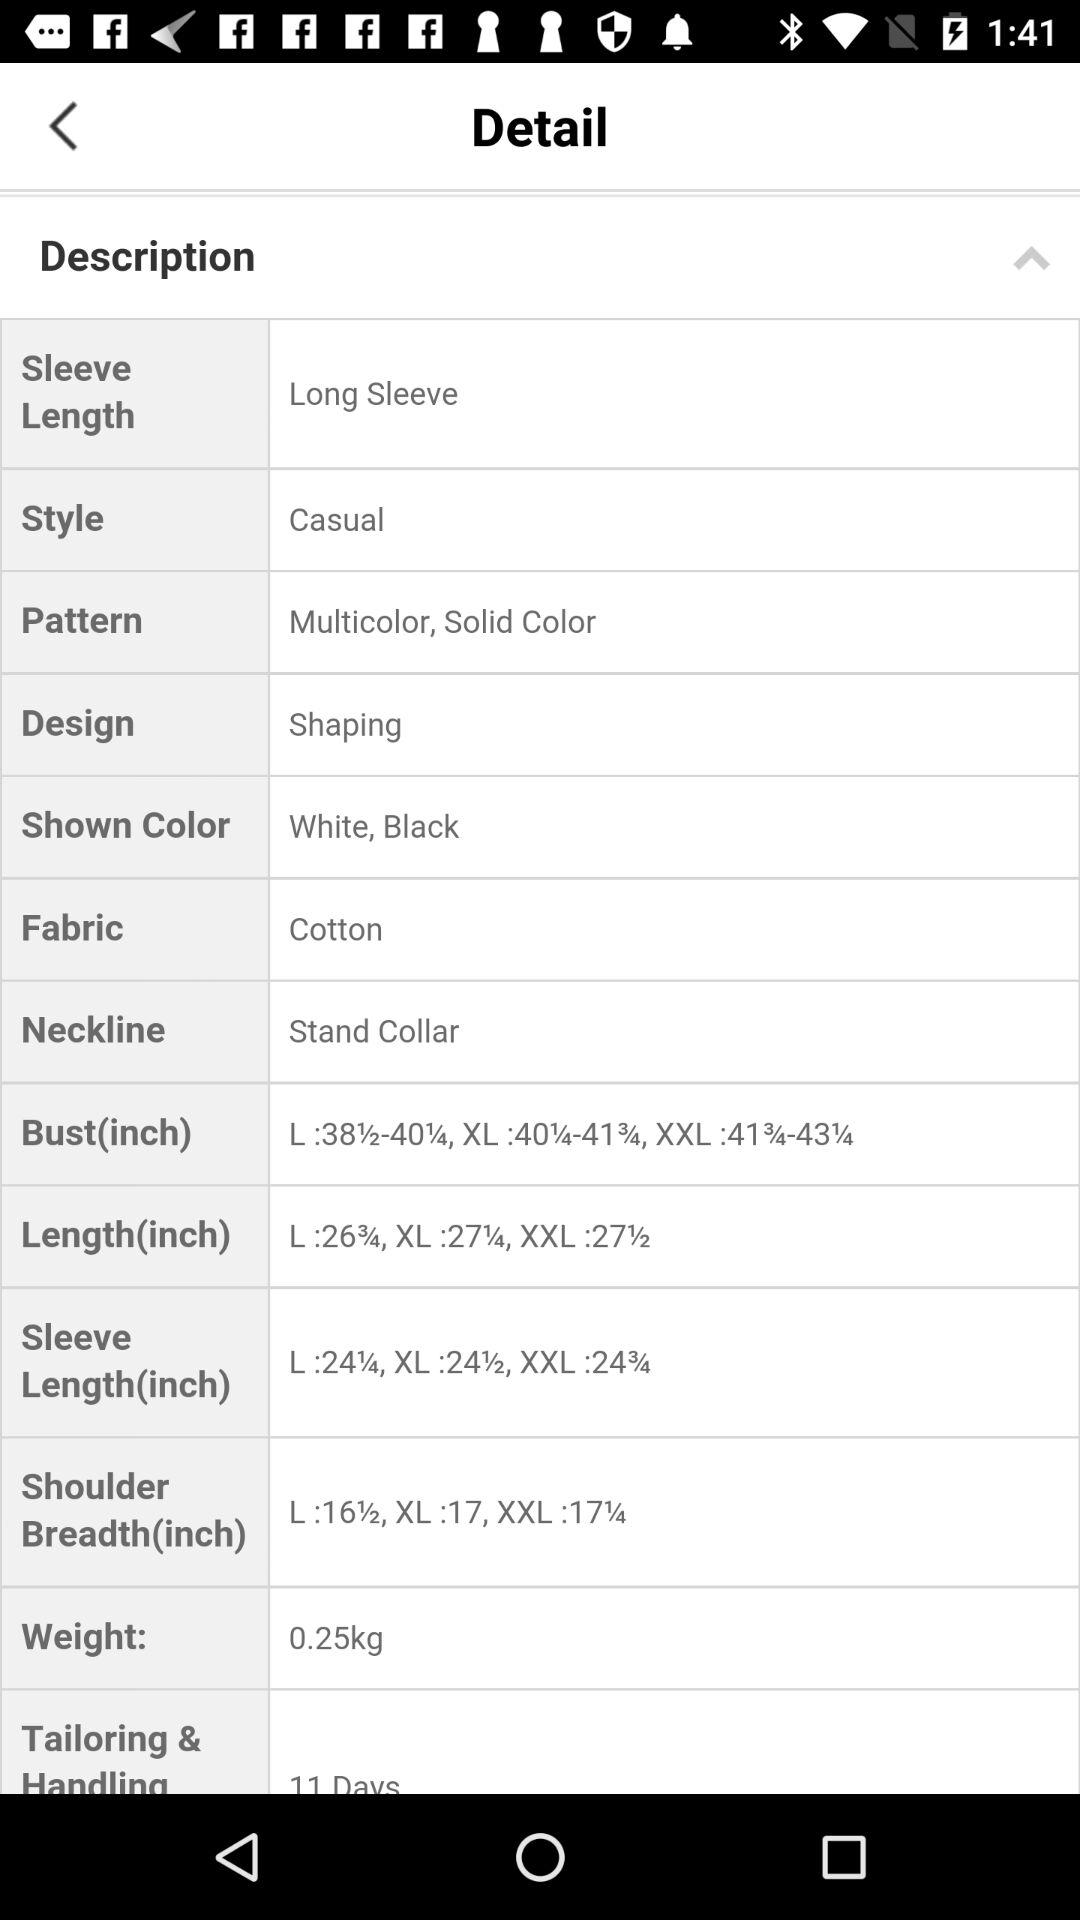What is the selected pattern? The selected patterns are: Multicolor, Solid Color. 